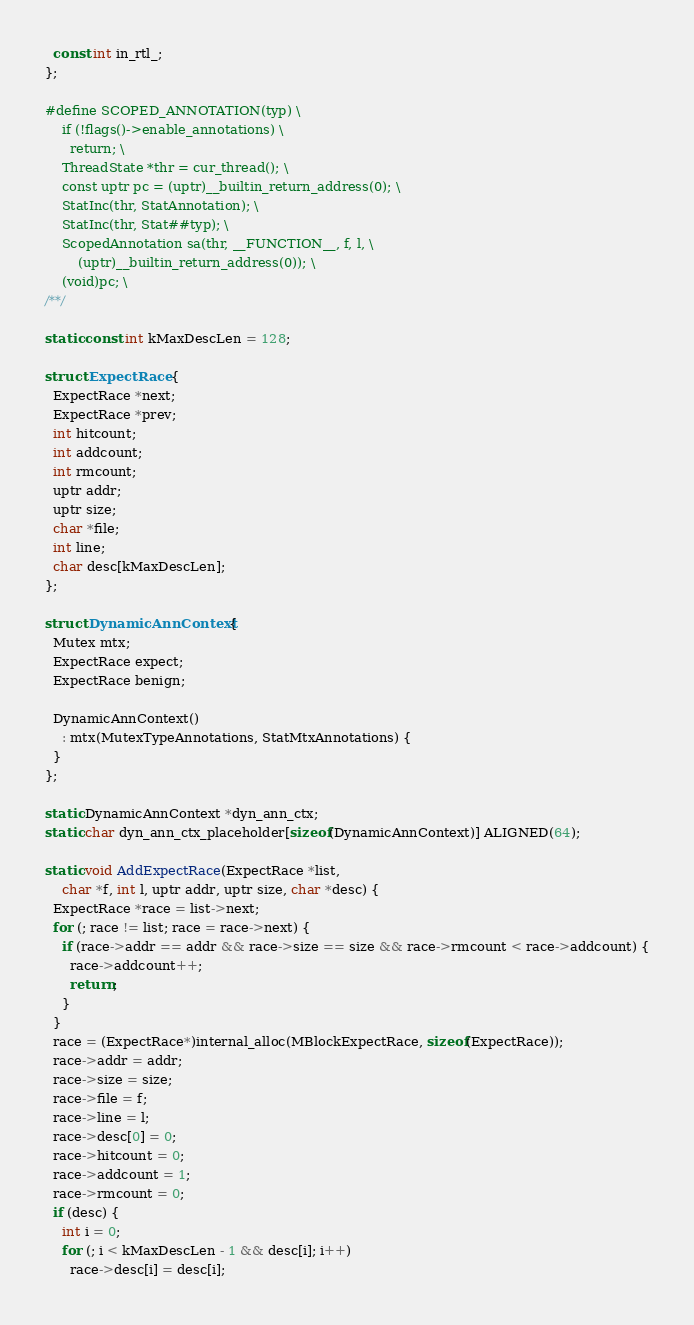Convert code to text. <code><loc_0><loc_0><loc_500><loc_500><_C++_>  const int in_rtl_;
};

#define SCOPED_ANNOTATION(typ) \
    if (!flags()->enable_annotations) \
      return; \
    ThreadState *thr = cur_thread(); \
    const uptr pc = (uptr)__builtin_return_address(0); \
    StatInc(thr, StatAnnotation); \
    StatInc(thr, Stat##typ); \
    ScopedAnnotation sa(thr, __FUNCTION__, f, l, \
        (uptr)__builtin_return_address(0)); \
    (void)pc; \
/**/

static const int kMaxDescLen = 128;

struct ExpectRace {
  ExpectRace *next;
  ExpectRace *prev;
  int hitcount;
  int addcount;
  int rmcount;
  uptr addr;
  uptr size;
  char *file;
  int line;
  char desc[kMaxDescLen];
};

struct DynamicAnnContext {
  Mutex mtx;
  ExpectRace expect;
  ExpectRace benign;

  DynamicAnnContext()
    : mtx(MutexTypeAnnotations, StatMtxAnnotations) {
  }
};

static DynamicAnnContext *dyn_ann_ctx;
static char dyn_ann_ctx_placeholder[sizeof(DynamicAnnContext)] ALIGNED(64);

static void AddExpectRace(ExpectRace *list,
    char *f, int l, uptr addr, uptr size, char *desc) {
  ExpectRace *race = list->next;
  for (; race != list; race = race->next) {
    if (race->addr == addr && race->size == size && race->rmcount < race->addcount) {
      race->addcount++;
      return;
    }
  }
  race = (ExpectRace*)internal_alloc(MBlockExpectRace, sizeof(ExpectRace));
  race->addr = addr;
  race->size = size;
  race->file = f;
  race->line = l;
  race->desc[0] = 0;
  race->hitcount = 0;
  race->addcount = 1;
  race->rmcount = 0;
  if (desc) {
    int i = 0;
    for (; i < kMaxDescLen - 1 && desc[i]; i++)
      race->desc[i] = desc[i];</code> 